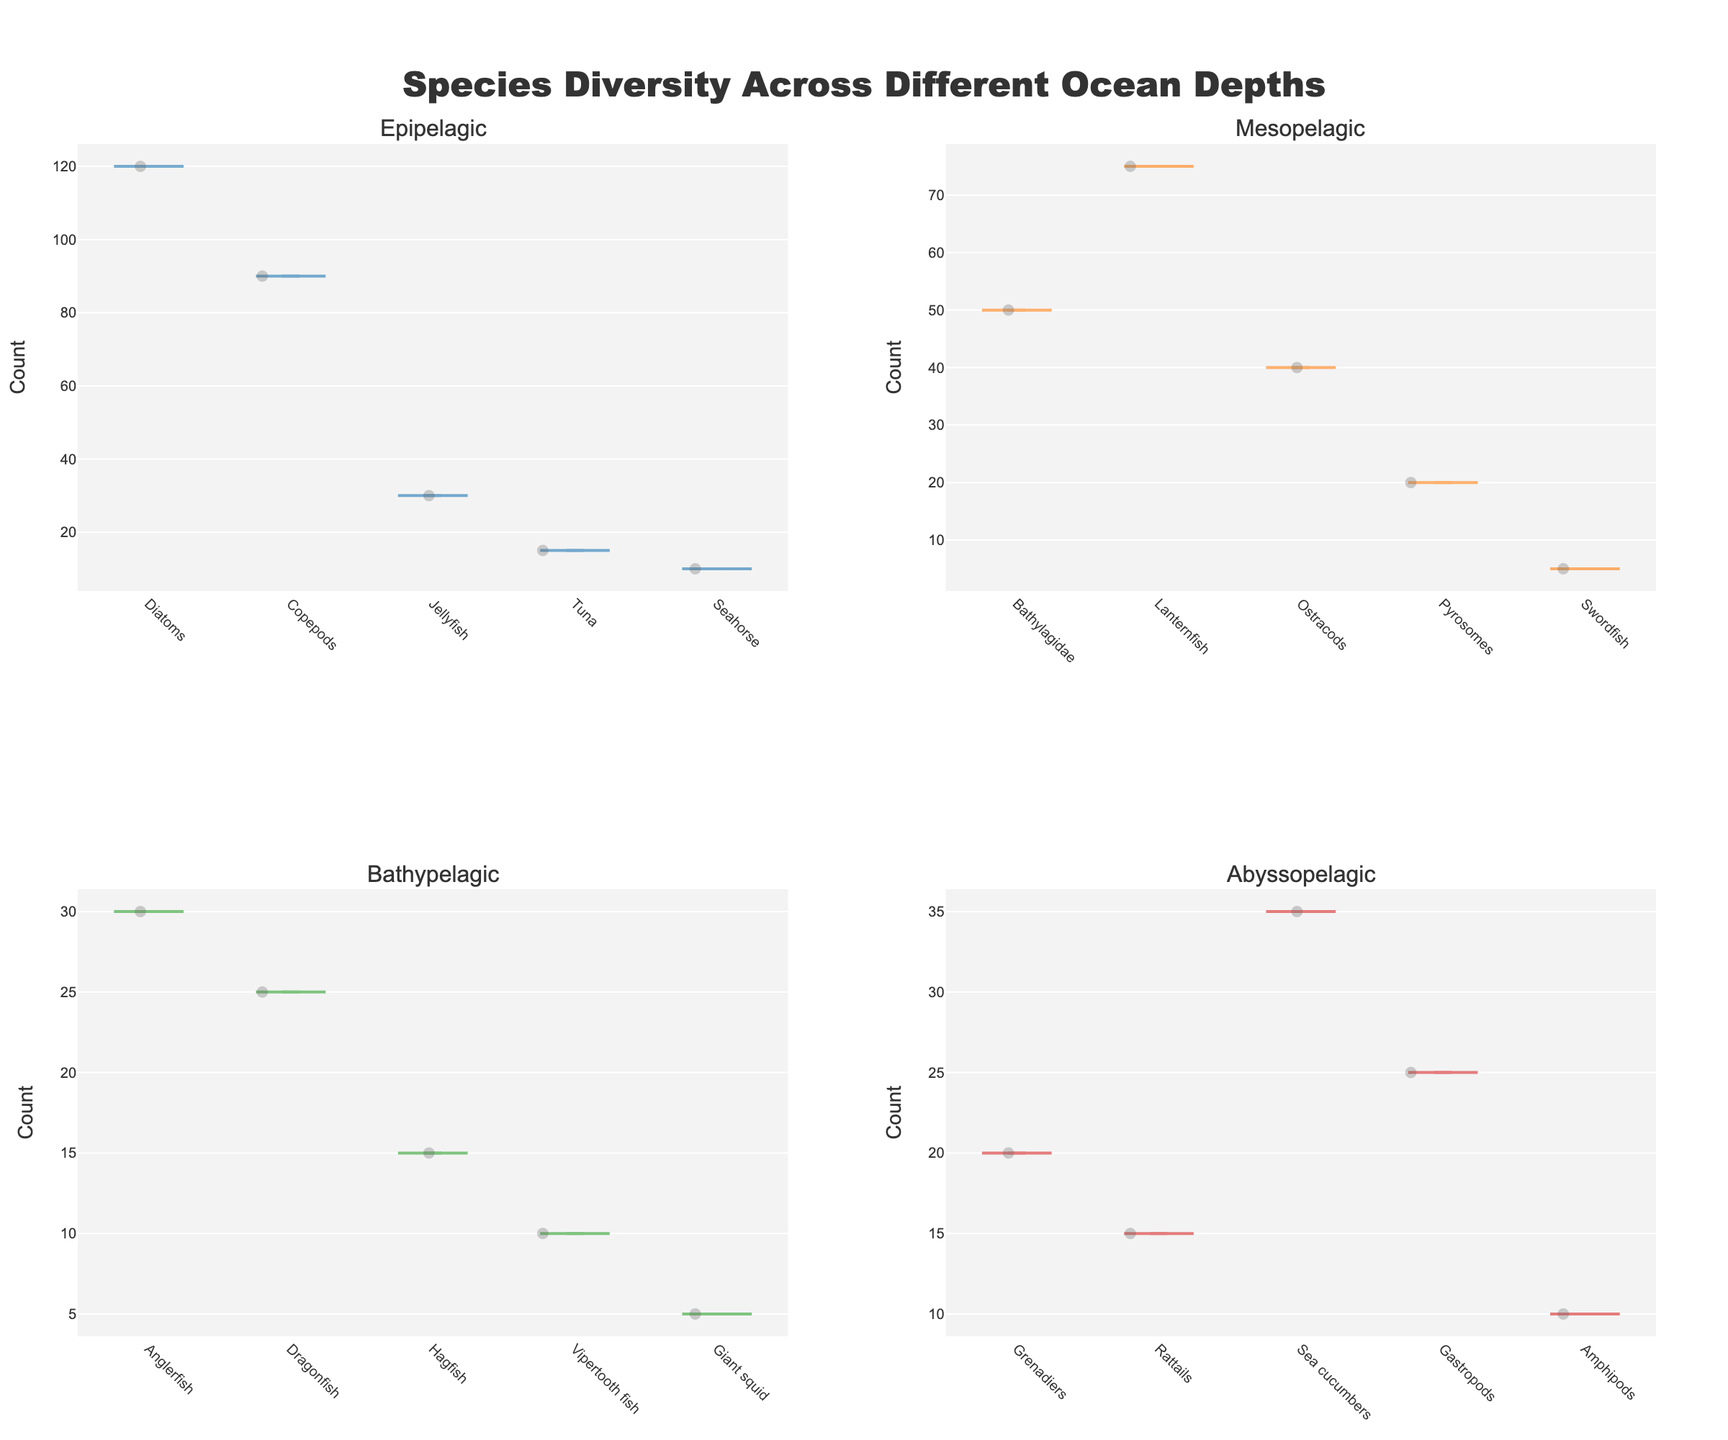What is the title of the figure? The title appears at the top of the figure: "Species Diversity Across Different Ocean Depths". This is clearly visible and is meant to describe the overall content of the plot.
Answer: Species Diversity Across Different Ocean Depths In which depth zone is Diatoms found, and what is their count? Diatoms are found in the Epipelagic zone as indicated by the data for that zone. Their count in this zone is represented by the length of the violin plot.
Answer: Epipelagic, 120 Which depth zone has the highest species count for Pyrosomes? By examining the violin plots, Pyrosomes are found in the Mesopelagic zone. The height of this violin plot indicates their count.
Answer: Mesopelagic Which two species in the Epipelagic zone have counts less than the Swordfish in the Mesopelagic zone? Swordfish in the Mesopelagic zone have a count of 5. Any species in the Epipelagic zone with counts less than 5 meet this requirement. By checking the Epipelagic violin plots, neither Tuna nor Seahorse counts fall below this threshold, thus no species in this zone have counts less than 5.
Answer: None Compare the species count medians for Anglerfish and Sea cucumbers. Which is higher? By examining the violin plots for the Bathypelagic and Abyssopelagic zones, the length of the plot for Anglerfish is centered around its count of 30, and Sea cucumbers around 35. Thus, Sea cucumbers have a higher median count.
Answer: Sea cucumbers What is the total count of all species in the Abyssopelagic zone? Summing up the counts in the Abyssopelagic zone: Grenadiers (20), Rattails (15), Sea cucumbers (35), Gastropods (25), Amphipods (10) results in 20+15+35+25+10 = 105.
Answer: 105 How many species are represented in each depth zone? By counting the unique species in each depth zone based on the violin plots:
Epipelagic: 5 species,
Mesopelagic: 5 species,
Bathypelagic: 5 species,
Abyssopelagic: 5 species.
Answer: 5 species each Which depth zone has the widest range of species counts? By looking at the spread of the violin plots for each depth zone, the Epipelagic zone with counts ranging from 10 (Seahorse) to 120 (Diatoms), has the widest spread.
Answer: Epipelagic Of the depth zones shown, which one has the least representation of species counted above 50? By observing the violin plots, only Bathypelagic has all species counts below 50, unlike other zones where at least one species has a count above 50.
Answer: Bathypelagic Which species is most abundant across the different depth zones? The species with the highest single count in any zone is most abundant. Based on the plot, Diatoms in the Epipelagic zone have the highest count (120).
Answer: Diatoms 